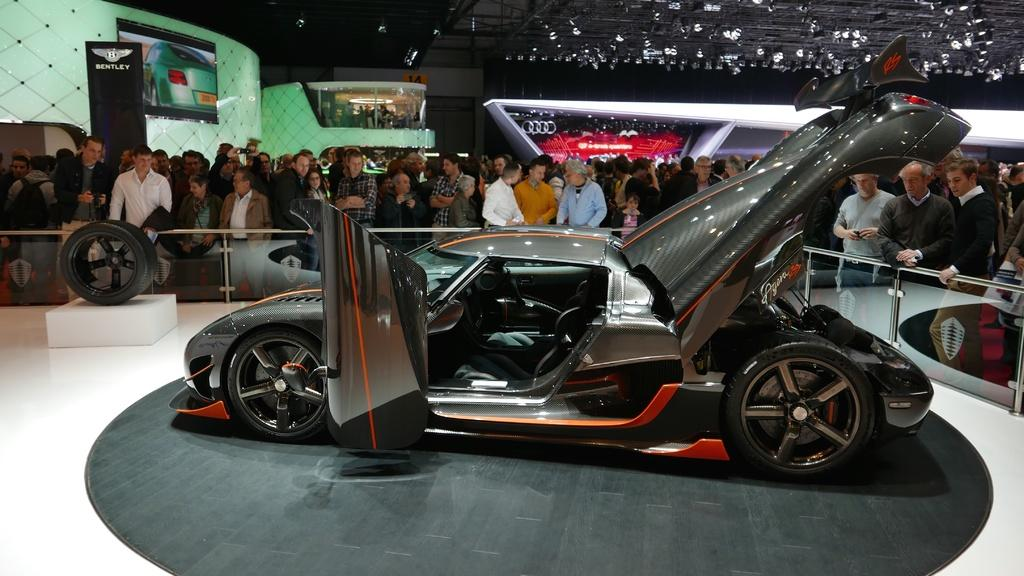What type of event is depicted in the image? The image appears to be a car expo. What is the main focus in the foreground of the image? There is a car in the foreground of the image. How are people interacting with the car in the image? There is a crowd around the car in the image. What can be seen in the background of the image? There are logos of other vehicles visible in the background. What type of plastic material can be seen growing from the trees in the image? There are no trees or plastic material present in the image. How does the spring season affect the car expo in the image? The image does not specify a season, so it cannot be determined how the spring season would affect the car expo. 